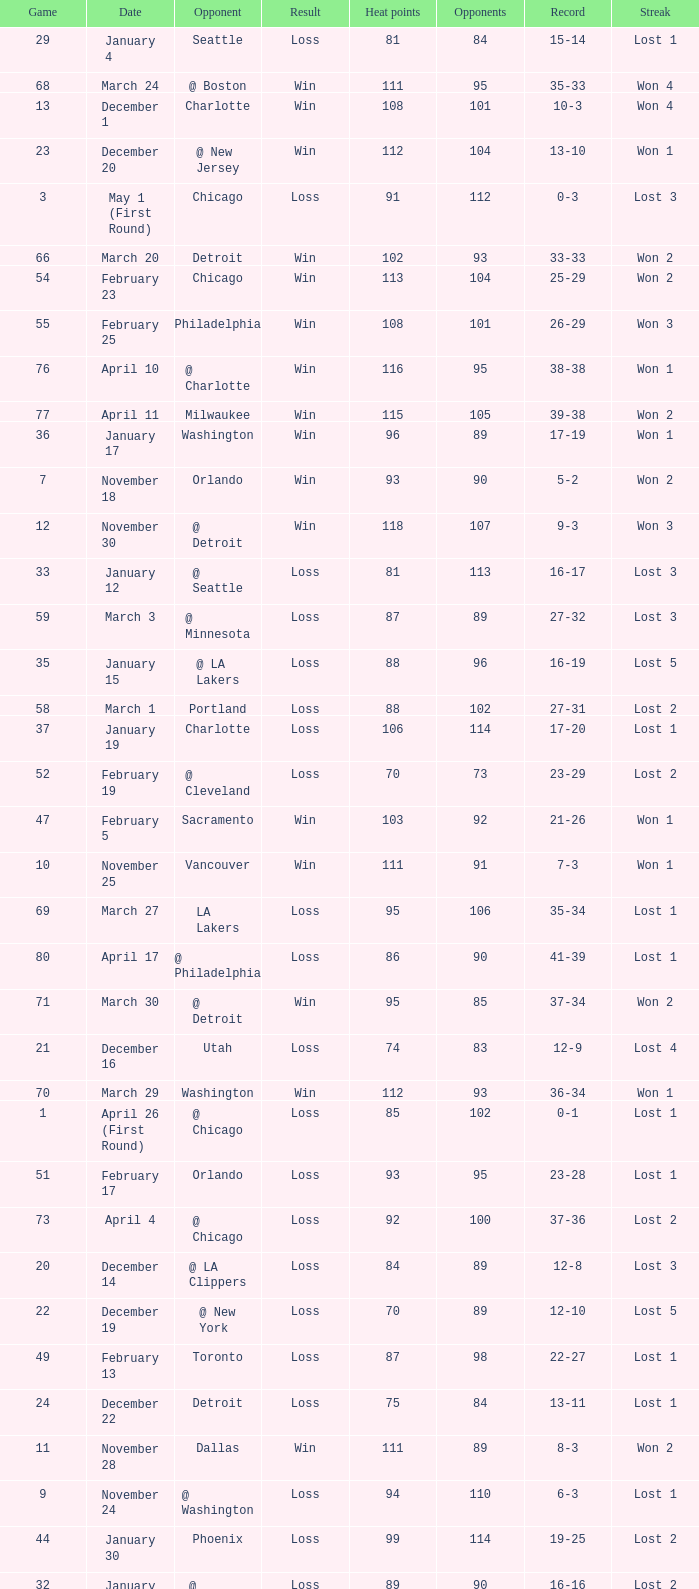What is the highest Game, when Opponents is less than 80, and when Record is "1-0"? 1.0. 